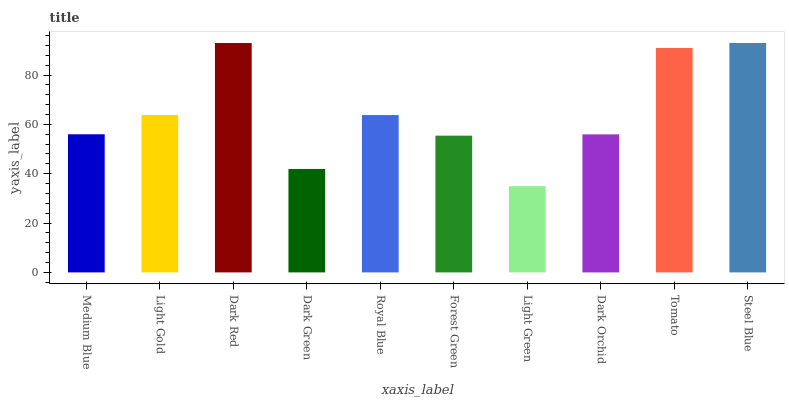Is Light Green the minimum?
Answer yes or no. Yes. Is Steel Blue the maximum?
Answer yes or no. Yes. Is Light Gold the minimum?
Answer yes or no. No. Is Light Gold the maximum?
Answer yes or no. No. Is Light Gold greater than Medium Blue?
Answer yes or no. Yes. Is Medium Blue less than Light Gold?
Answer yes or no. Yes. Is Medium Blue greater than Light Gold?
Answer yes or no. No. Is Light Gold less than Medium Blue?
Answer yes or no. No. Is Royal Blue the high median?
Answer yes or no. Yes. Is Medium Blue the low median?
Answer yes or no. Yes. Is Light Gold the high median?
Answer yes or no. No. Is Light Gold the low median?
Answer yes or no. No. 